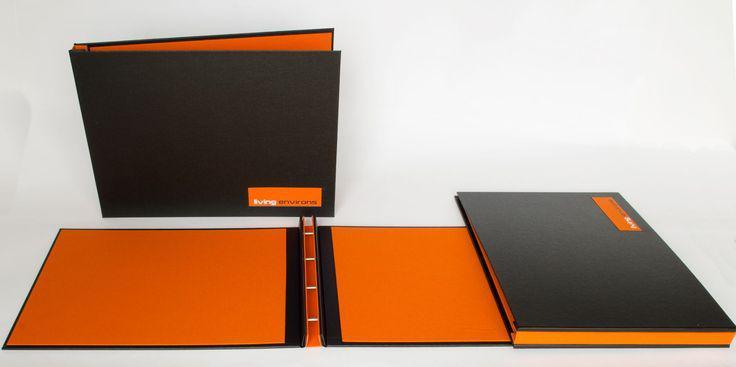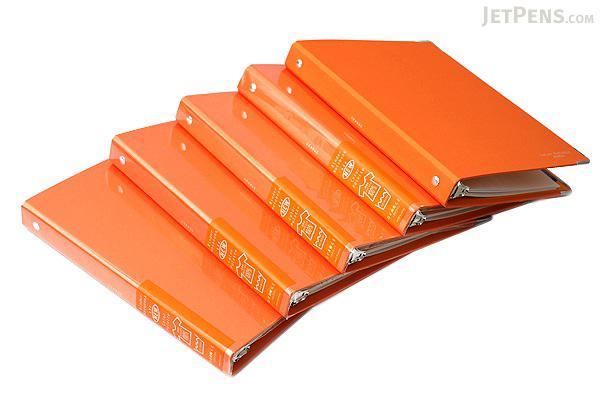The first image is the image on the left, the second image is the image on the right. Examine the images to the left and right. Is the description "In one image, at least one orange notebook is closed and lying flat with the opening to the back, while the second image shows at least one notebook that is orange and black with no visible contents." accurate? Answer yes or no. Yes. The first image is the image on the left, the second image is the image on the right. Considering the images on both sides, is "An image shows a stack of at least eight binders that appears to sit on a flat surface." valid? Answer yes or no. No. 